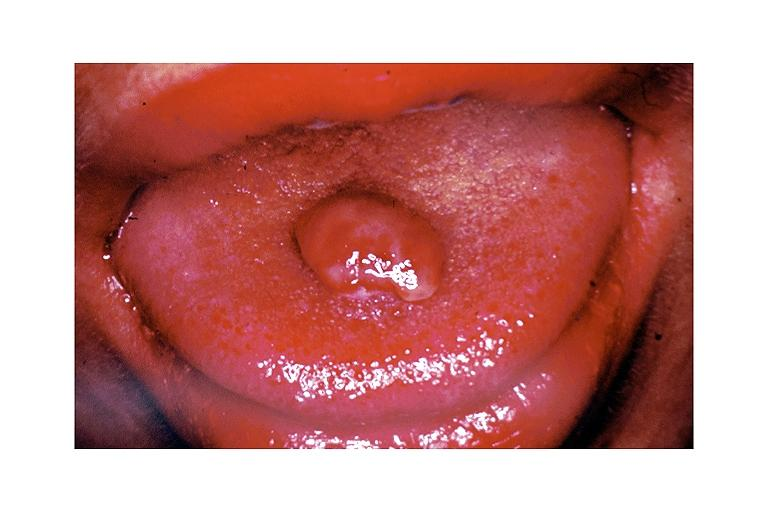does this image show pyogenic granuloma?
Answer the question using a single word or phrase. Yes 